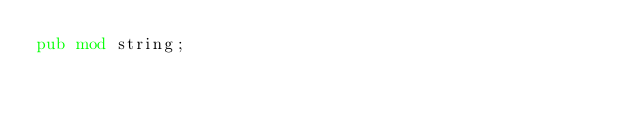Convert code to text. <code><loc_0><loc_0><loc_500><loc_500><_Rust_>pub mod string;
</code> 